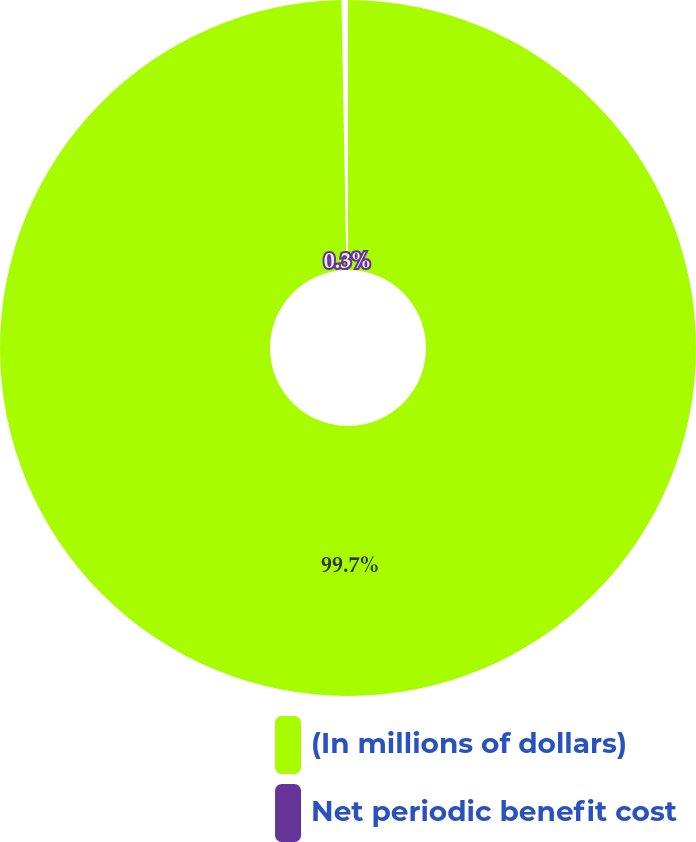<chart> <loc_0><loc_0><loc_500><loc_500><pie_chart><fcel>(In millions of dollars)<fcel>Net periodic benefit cost<nl><fcel>99.7%<fcel>0.3%<nl></chart> 